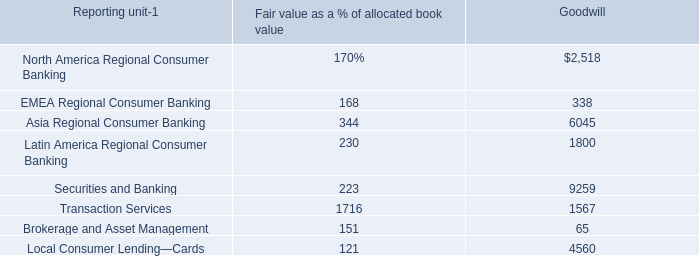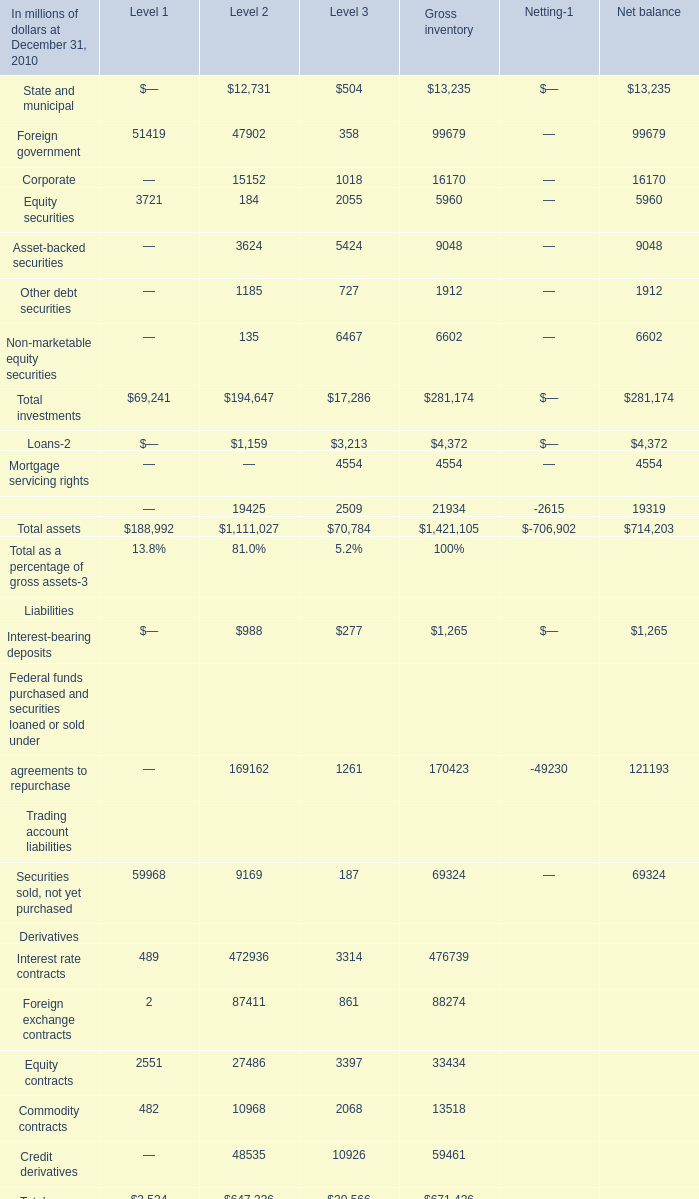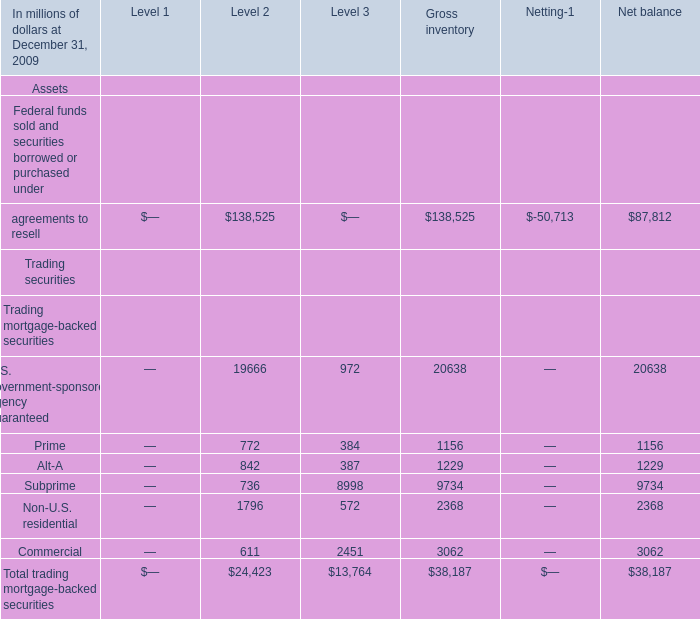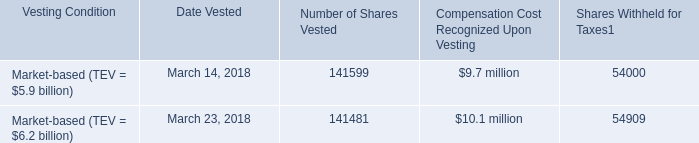What is the average amount of Securities and Banking of Goodwill, and Foreign government of Level 2 ? 
Computations: ((9259.0 + 47902.0) / 2)
Answer: 28580.5. 